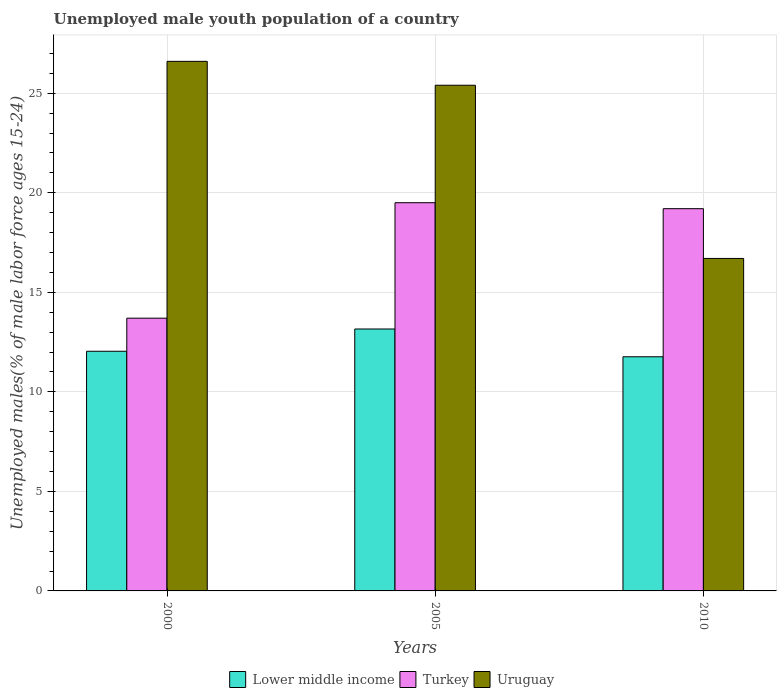How many bars are there on the 1st tick from the left?
Make the answer very short. 3. What is the label of the 2nd group of bars from the left?
Offer a terse response. 2005. What is the percentage of unemployed male youth population in Turkey in 2000?
Keep it short and to the point. 13.7. Across all years, what is the maximum percentage of unemployed male youth population in Turkey?
Your answer should be very brief. 19.5. Across all years, what is the minimum percentage of unemployed male youth population in Lower middle income?
Your answer should be compact. 11.76. What is the total percentage of unemployed male youth population in Turkey in the graph?
Your answer should be very brief. 52.4. What is the difference between the percentage of unemployed male youth population in Uruguay in 2005 and that in 2010?
Your answer should be compact. 8.7. What is the difference between the percentage of unemployed male youth population in Lower middle income in 2000 and the percentage of unemployed male youth population in Turkey in 2010?
Provide a succinct answer. -7.16. What is the average percentage of unemployed male youth population in Uruguay per year?
Give a very brief answer. 22.9. In the year 2010, what is the difference between the percentage of unemployed male youth population in Lower middle income and percentage of unemployed male youth population in Uruguay?
Offer a very short reply. -4.94. In how many years, is the percentage of unemployed male youth population in Uruguay greater than 24 %?
Ensure brevity in your answer.  2. What is the ratio of the percentage of unemployed male youth population in Uruguay in 2000 to that in 2010?
Provide a succinct answer. 1.59. Is the percentage of unemployed male youth population in Turkey in 2000 less than that in 2010?
Provide a succinct answer. Yes. What is the difference between the highest and the second highest percentage of unemployed male youth population in Lower middle income?
Keep it short and to the point. 1.12. What is the difference between the highest and the lowest percentage of unemployed male youth population in Turkey?
Give a very brief answer. 5.8. In how many years, is the percentage of unemployed male youth population in Uruguay greater than the average percentage of unemployed male youth population in Uruguay taken over all years?
Keep it short and to the point. 2. Is the sum of the percentage of unemployed male youth population in Uruguay in 2000 and 2010 greater than the maximum percentage of unemployed male youth population in Lower middle income across all years?
Give a very brief answer. Yes. What does the 3rd bar from the left in 2005 represents?
Your response must be concise. Uruguay. How many bars are there?
Offer a very short reply. 9. How many years are there in the graph?
Your answer should be very brief. 3. What is the difference between two consecutive major ticks on the Y-axis?
Keep it short and to the point. 5. How are the legend labels stacked?
Keep it short and to the point. Horizontal. What is the title of the graph?
Provide a succinct answer. Unemployed male youth population of a country. What is the label or title of the X-axis?
Offer a terse response. Years. What is the label or title of the Y-axis?
Offer a very short reply. Unemployed males(% of male labor force ages 15-24). What is the Unemployed males(% of male labor force ages 15-24) in Lower middle income in 2000?
Provide a succinct answer. 12.04. What is the Unemployed males(% of male labor force ages 15-24) in Turkey in 2000?
Offer a terse response. 13.7. What is the Unemployed males(% of male labor force ages 15-24) in Uruguay in 2000?
Your answer should be compact. 26.6. What is the Unemployed males(% of male labor force ages 15-24) in Lower middle income in 2005?
Keep it short and to the point. 13.16. What is the Unemployed males(% of male labor force ages 15-24) in Turkey in 2005?
Your answer should be compact. 19.5. What is the Unemployed males(% of male labor force ages 15-24) of Uruguay in 2005?
Keep it short and to the point. 25.4. What is the Unemployed males(% of male labor force ages 15-24) in Lower middle income in 2010?
Offer a terse response. 11.76. What is the Unemployed males(% of male labor force ages 15-24) of Turkey in 2010?
Offer a very short reply. 19.2. What is the Unemployed males(% of male labor force ages 15-24) in Uruguay in 2010?
Offer a very short reply. 16.7. Across all years, what is the maximum Unemployed males(% of male labor force ages 15-24) of Lower middle income?
Provide a short and direct response. 13.16. Across all years, what is the maximum Unemployed males(% of male labor force ages 15-24) in Uruguay?
Keep it short and to the point. 26.6. Across all years, what is the minimum Unemployed males(% of male labor force ages 15-24) in Lower middle income?
Ensure brevity in your answer.  11.76. Across all years, what is the minimum Unemployed males(% of male labor force ages 15-24) of Turkey?
Ensure brevity in your answer.  13.7. Across all years, what is the minimum Unemployed males(% of male labor force ages 15-24) in Uruguay?
Your answer should be very brief. 16.7. What is the total Unemployed males(% of male labor force ages 15-24) in Lower middle income in the graph?
Provide a short and direct response. 36.96. What is the total Unemployed males(% of male labor force ages 15-24) in Turkey in the graph?
Your answer should be very brief. 52.4. What is the total Unemployed males(% of male labor force ages 15-24) of Uruguay in the graph?
Give a very brief answer. 68.7. What is the difference between the Unemployed males(% of male labor force ages 15-24) in Lower middle income in 2000 and that in 2005?
Your response must be concise. -1.12. What is the difference between the Unemployed males(% of male labor force ages 15-24) of Lower middle income in 2000 and that in 2010?
Provide a short and direct response. 0.28. What is the difference between the Unemployed males(% of male labor force ages 15-24) of Lower middle income in 2005 and that in 2010?
Make the answer very short. 1.4. What is the difference between the Unemployed males(% of male labor force ages 15-24) in Turkey in 2005 and that in 2010?
Offer a terse response. 0.3. What is the difference between the Unemployed males(% of male labor force ages 15-24) in Uruguay in 2005 and that in 2010?
Make the answer very short. 8.7. What is the difference between the Unemployed males(% of male labor force ages 15-24) in Lower middle income in 2000 and the Unemployed males(% of male labor force ages 15-24) in Turkey in 2005?
Offer a terse response. -7.46. What is the difference between the Unemployed males(% of male labor force ages 15-24) of Lower middle income in 2000 and the Unemployed males(% of male labor force ages 15-24) of Uruguay in 2005?
Ensure brevity in your answer.  -13.36. What is the difference between the Unemployed males(% of male labor force ages 15-24) in Turkey in 2000 and the Unemployed males(% of male labor force ages 15-24) in Uruguay in 2005?
Make the answer very short. -11.7. What is the difference between the Unemployed males(% of male labor force ages 15-24) of Lower middle income in 2000 and the Unemployed males(% of male labor force ages 15-24) of Turkey in 2010?
Keep it short and to the point. -7.16. What is the difference between the Unemployed males(% of male labor force ages 15-24) of Lower middle income in 2000 and the Unemployed males(% of male labor force ages 15-24) of Uruguay in 2010?
Your answer should be very brief. -4.66. What is the difference between the Unemployed males(% of male labor force ages 15-24) of Turkey in 2000 and the Unemployed males(% of male labor force ages 15-24) of Uruguay in 2010?
Your answer should be compact. -3. What is the difference between the Unemployed males(% of male labor force ages 15-24) of Lower middle income in 2005 and the Unemployed males(% of male labor force ages 15-24) of Turkey in 2010?
Provide a succinct answer. -6.04. What is the difference between the Unemployed males(% of male labor force ages 15-24) in Lower middle income in 2005 and the Unemployed males(% of male labor force ages 15-24) in Uruguay in 2010?
Your answer should be very brief. -3.54. What is the average Unemployed males(% of male labor force ages 15-24) in Lower middle income per year?
Offer a very short reply. 12.32. What is the average Unemployed males(% of male labor force ages 15-24) of Turkey per year?
Ensure brevity in your answer.  17.47. What is the average Unemployed males(% of male labor force ages 15-24) in Uruguay per year?
Offer a very short reply. 22.9. In the year 2000, what is the difference between the Unemployed males(% of male labor force ages 15-24) of Lower middle income and Unemployed males(% of male labor force ages 15-24) of Turkey?
Your response must be concise. -1.66. In the year 2000, what is the difference between the Unemployed males(% of male labor force ages 15-24) of Lower middle income and Unemployed males(% of male labor force ages 15-24) of Uruguay?
Offer a very short reply. -14.56. In the year 2000, what is the difference between the Unemployed males(% of male labor force ages 15-24) of Turkey and Unemployed males(% of male labor force ages 15-24) of Uruguay?
Your answer should be compact. -12.9. In the year 2005, what is the difference between the Unemployed males(% of male labor force ages 15-24) of Lower middle income and Unemployed males(% of male labor force ages 15-24) of Turkey?
Ensure brevity in your answer.  -6.34. In the year 2005, what is the difference between the Unemployed males(% of male labor force ages 15-24) of Lower middle income and Unemployed males(% of male labor force ages 15-24) of Uruguay?
Your response must be concise. -12.24. In the year 2010, what is the difference between the Unemployed males(% of male labor force ages 15-24) in Lower middle income and Unemployed males(% of male labor force ages 15-24) in Turkey?
Ensure brevity in your answer.  -7.44. In the year 2010, what is the difference between the Unemployed males(% of male labor force ages 15-24) of Lower middle income and Unemployed males(% of male labor force ages 15-24) of Uruguay?
Keep it short and to the point. -4.94. What is the ratio of the Unemployed males(% of male labor force ages 15-24) in Lower middle income in 2000 to that in 2005?
Make the answer very short. 0.92. What is the ratio of the Unemployed males(% of male labor force ages 15-24) in Turkey in 2000 to that in 2005?
Your answer should be very brief. 0.7. What is the ratio of the Unemployed males(% of male labor force ages 15-24) in Uruguay in 2000 to that in 2005?
Provide a succinct answer. 1.05. What is the ratio of the Unemployed males(% of male labor force ages 15-24) of Lower middle income in 2000 to that in 2010?
Provide a succinct answer. 1.02. What is the ratio of the Unemployed males(% of male labor force ages 15-24) in Turkey in 2000 to that in 2010?
Ensure brevity in your answer.  0.71. What is the ratio of the Unemployed males(% of male labor force ages 15-24) of Uruguay in 2000 to that in 2010?
Make the answer very short. 1.59. What is the ratio of the Unemployed males(% of male labor force ages 15-24) of Lower middle income in 2005 to that in 2010?
Offer a terse response. 1.12. What is the ratio of the Unemployed males(% of male labor force ages 15-24) of Turkey in 2005 to that in 2010?
Offer a very short reply. 1.02. What is the ratio of the Unemployed males(% of male labor force ages 15-24) in Uruguay in 2005 to that in 2010?
Offer a very short reply. 1.52. What is the difference between the highest and the second highest Unemployed males(% of male labor force ages 15-24) in Lower middle income?
Give a very brief answer. 1.12. What is the difference between the highest and the second highest Unemployed males(% of male labor force ages 15-24) of Uruguay?
Keep it short and to the point. 1.2. What is the difference between the highest and the lowest Unemployed males(% of male labor force ages 15-24) in Lower middle income?
Offer a very short reply. 1.4. What is the difference between the highest and the lowest Unemployed males(% of male labor force ages 15-24) of Turkey?
Offer a terse response. 5.8. 